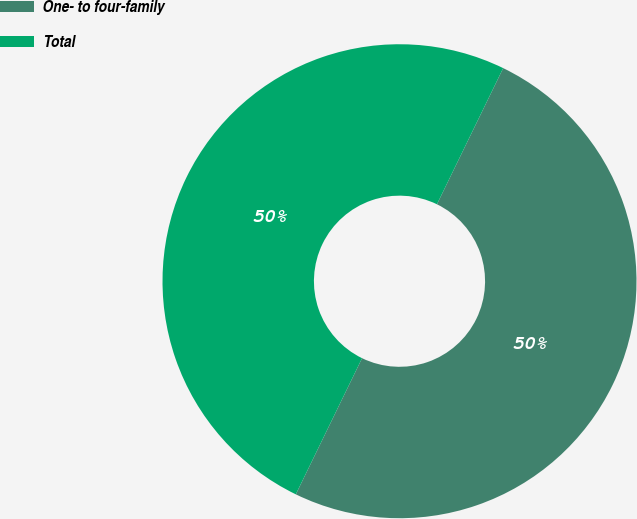<chart> <loc_0><loc_0><loc_500><loc_500><pie_chart><fcel>One- to four-family<fcel>Total<nl><fcel>50.0%<fcel>50.0%<nl></chart> 